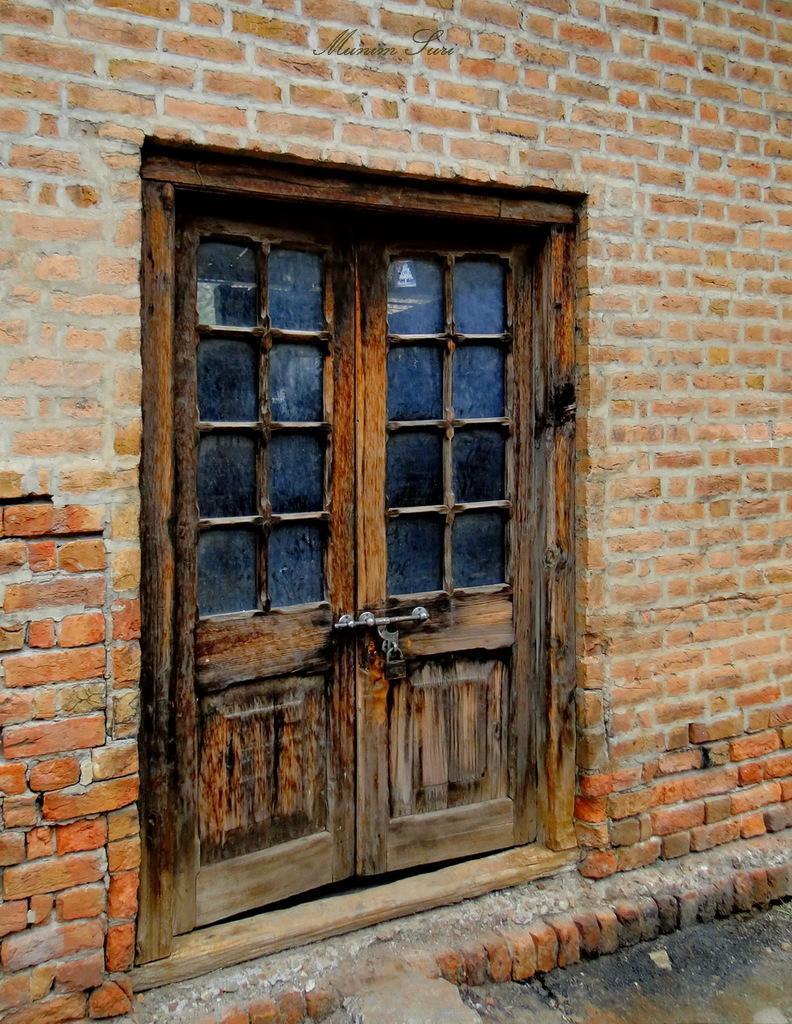Please provide a concise description of this image. In this image we can see the wooden door. Here we can see the brick wall. 